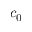<formula> <loc_0><loc_0><loc_500><loc_500>c _ { 0 }</formula> 